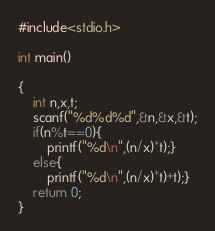<code> <loc_0><loc_0><loc_500><loc_500><_C_>#include<stdio.h>
 
int main()
 
{
    int n,x,t;
    scanf("%d%d%d",&n,&x,&t);
    if(n%t==0){
    	printf("%d\n",(n/x)*t);}
  	else{
      	printf("%d\n",(n/x)*t)+t);}
  	return 0;
}</code> 